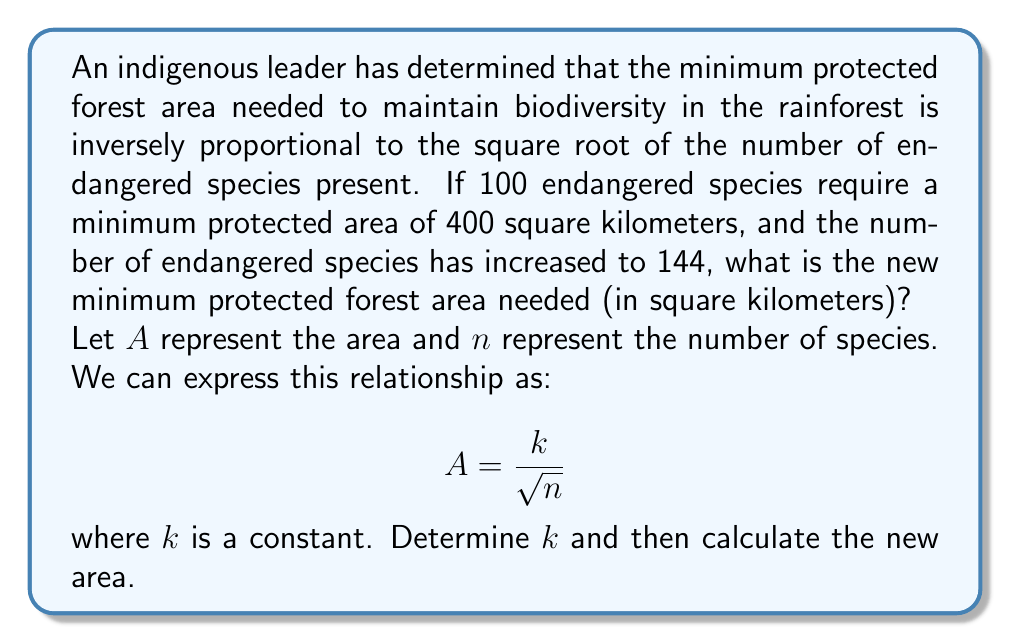Help me with this question. 1) First, let's determine the constant $k$ using the given information:
   $A = 400$ when $n = 100$
   
   $$400 = \frac{k}{\sqrt{100}}$$
   $$400 = \frac{k}{10}$$
   $$k = 400 * 10 = 4000$$

2) Now that we know $k = 4000$, we can use this to find the new area when $n = 144$:

   $$A = \frac{4000}{\sqrt{144}}$$

3) Simplify $\sqrt{144}$:
   $$A = \frac{4000}{12}$$

4) Perform the division:
   $$A = \frac{1000}{3} \approx 333.33$$

5) Round to the nearest whole number, as we're dealing with square kilometers:
   $$A \approx 333 \text{ sq km}$$
Answer: 333 sq km 